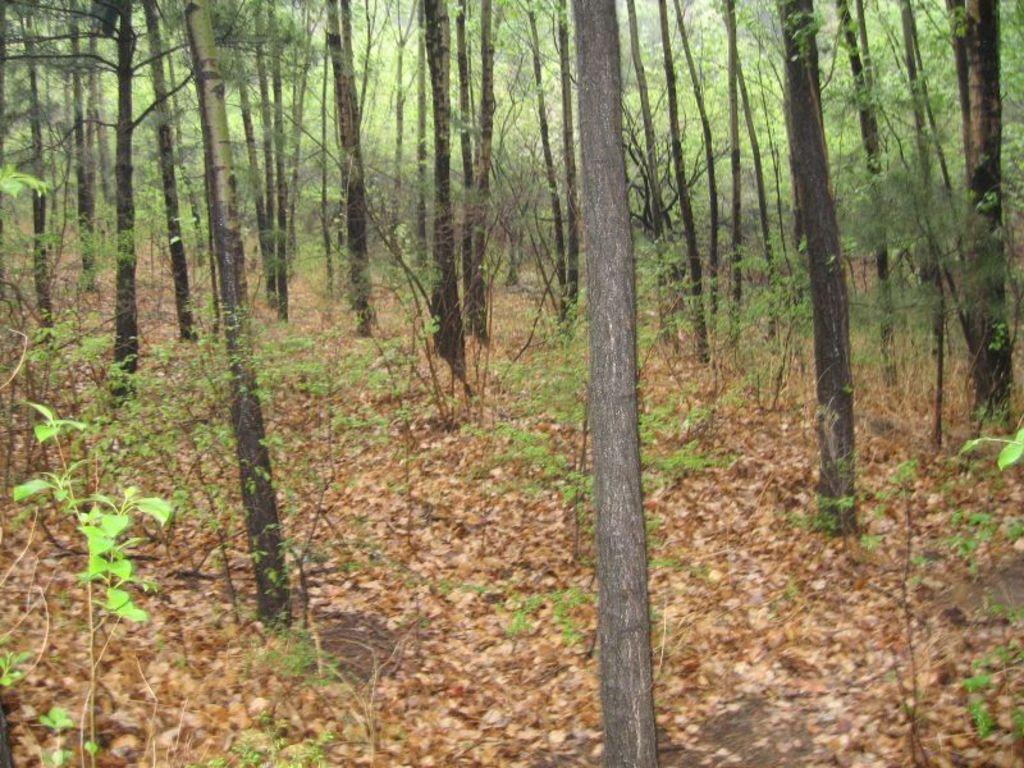Where was the image taken? The image was clicked outside. What can be seen in the foreground of the image? There are plants and dry leaves lying on the ground in the foreground of the image. What type of vegetation is visible in the image? There are trees visible in the image, and their trunks are also visible. Can you see any eyes or masks on the trees in the image? No, there are no eyes or masks present on the trees in the image. Are there any bats hanging from the trees in the image? No, there are no bats visible in the image. 